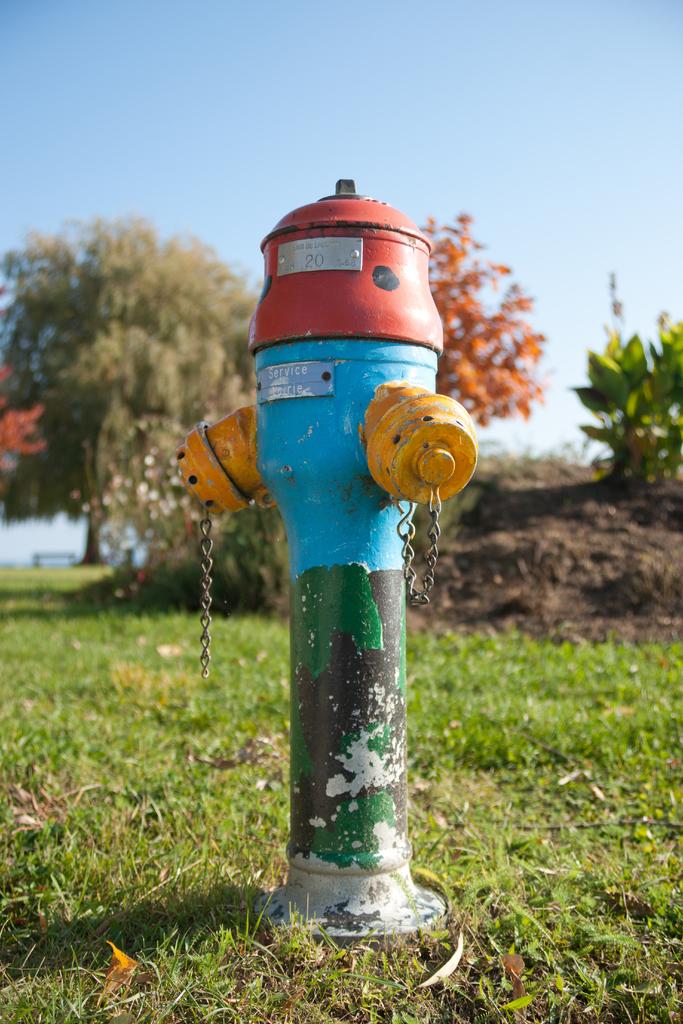What is the number on this hydrant?
Keep it short and to the point. 20. How many colors does the hydrant have?
Make the answer very short. Answering does not require reading text in the image. 